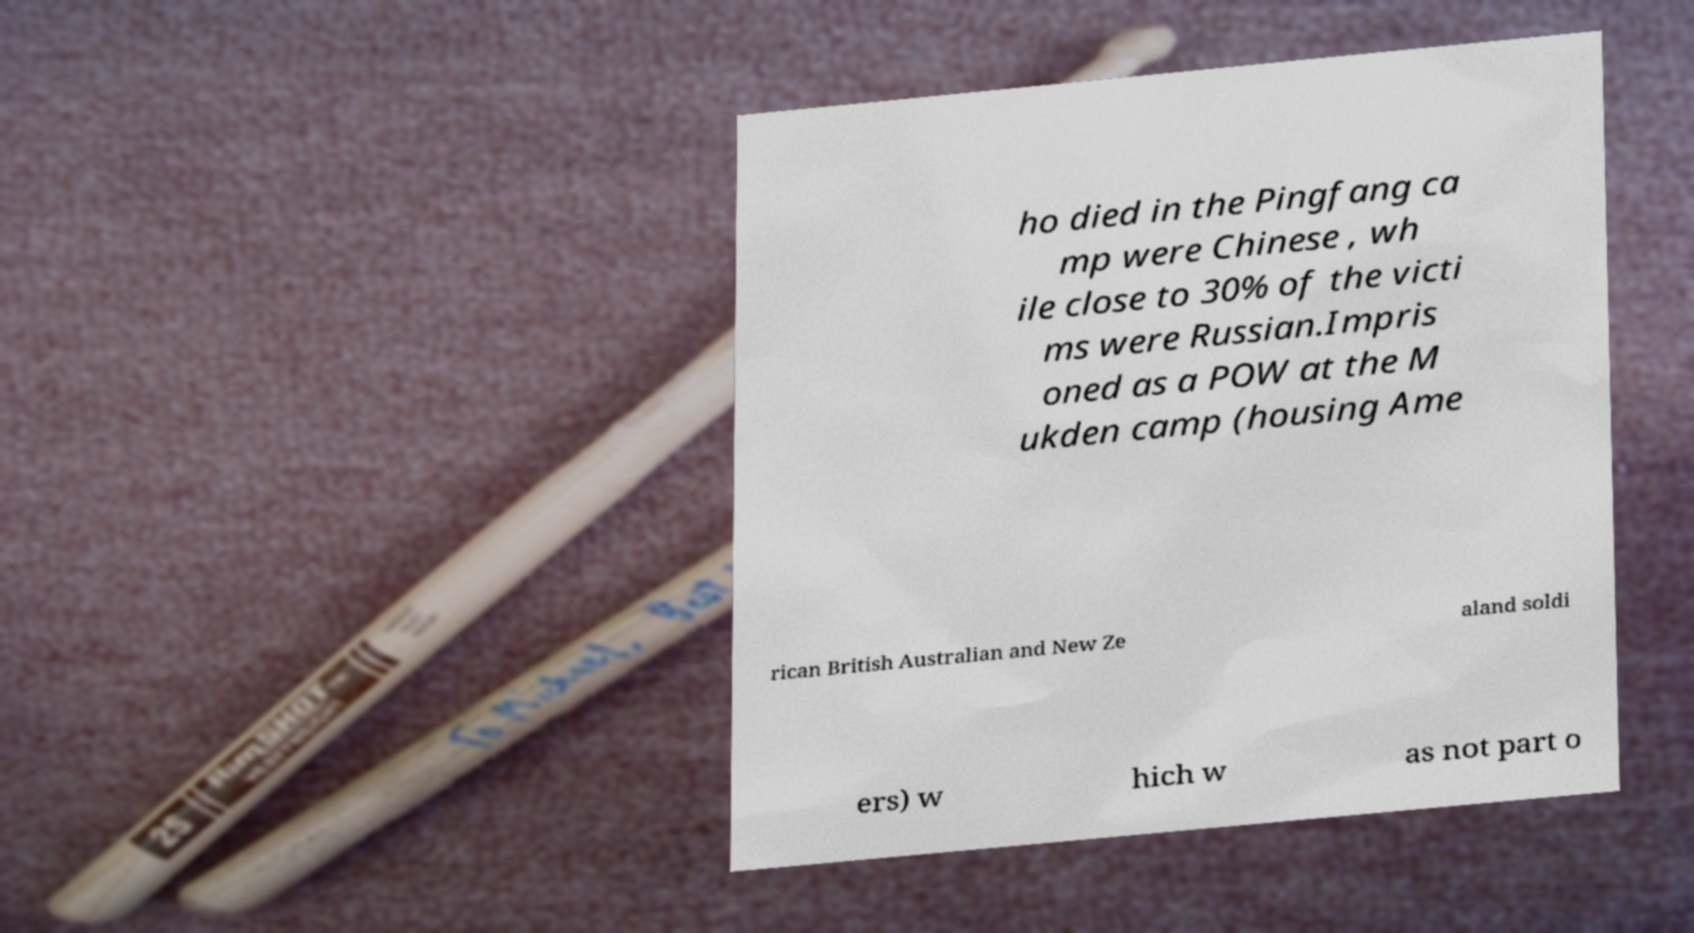What messages or text are displayed in this image? I need them in a readable, typed format. ho died in the Pingfang ca mp were Chinese , wh ile close to 30% of the victi ms were Russian.Impris oned as a POW at the M ukden camp (housing Ame rican British Australian and New Ze aland soldi ers) w hich w as not part o 